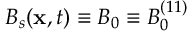<formula> <loc_0><loc_0><loc_500><loc_500>B _ { s } ( x , t ) \equiv B _ { 0 } \equiv B _ { 0 } ^ { ( 1 1 ) }</formula> 